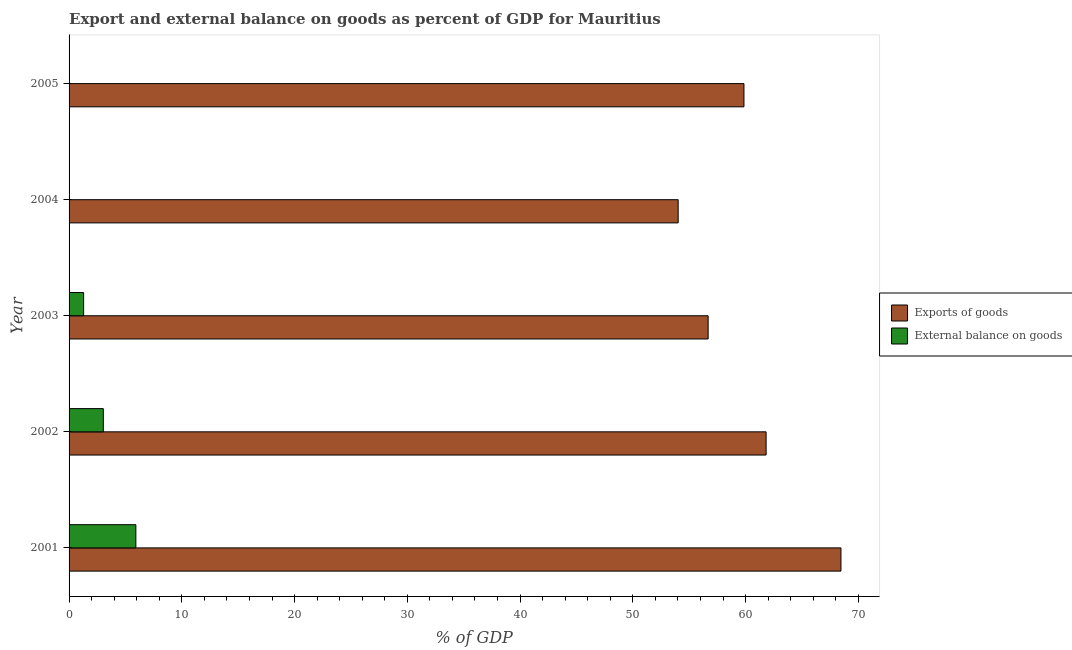How many different coloured bars are there?
Your response must be concise. 2. Are the number of bars per tick equal to the number of legend labels?
Offer a very short reply. No. What is the label of the 3rd group of bars from the top?
Make the answer very short. 2003. In how many cases, is the number of bars for a given year not equal to the number of legend labels?
Your response must be concise. 2. What is the export of goods as percentage of gdp in 2001?
Your answer should be compact. 68.46. Across all years, what is the maximum export of goods as percentage of gdp?
Provide a short and direct response. 68.46. Across all years, what is the minimum export of goods as percentage of gdp?
Ensure brevity in your answer.  54.02. In which year was the export of goods as percentage of gdp maximum?
Make the answer very short. 2001. What is the total external balance on goods as percentage of gdp in the graph?
Provide a succinct answer. 10.25. What is the difference between the export of goods as percentage of gdp in 2002 and that in 2005?
Your answer should be compact. 1.96. What is the difference between the external balance on goods as percentage of gdp in 2004 and the export of goods as percentage of gdp in 2005?
Offer a very short reply. -59.85. What is the average external balance on goods as percentage of gdp per year?
Keep it short and to the point. 2.05. In the year 2002, what is the difference between the export of goods as percentage of gdp and external balance on goods as percentage of gdp?
Your answer should be compact. 58.78. In how many years, is the external balance on goods as percentage of gdp greater than 44 %?
Provide a succinct answer. 0. What is the ratio of the export of goods as percentage of gdp in 2002 to that in 2005?
Give a very brief answer. 1.03. Is the external balance on goods as percentage of gdp in 2001 less than that in 2002?
Give a very brief answer. No. What is the difference between the highest and the second highest export of goods as percentage of gdp?
Provide a succinct answer. 6.64. What is the difference between the highest and the lowest external balance on goods as percentage of gdp?
Provide a succinct answer. 5.92. In how many years, is the export of goods as percentage of gdp greater than the average export of goods as percentage of gdp taken over all years?
Make the answer very short. 2. Are all the bars in the graph horizontal?
Give a very brief answer. Yes. How many years are there in the graph?
Provide a short and direct response. 5. What is the difference between two consecutive major ticks on the X-axis?
Offer a terse response. 10. Are the values on the major ticks of X-axis written in scientific E-notation?
Provide a succinct answer. No. Does the graph contain any zero values?
Your answer should be very brief. Yes. Does the graph contain grids?
Your response must be concise. No. How many legend labels are there?
Your answer should be very brief. 2. What is the title of the graph?
Give a very brief answer. Export and external balance on goods as percent of GDP for Mauritius. What is the label or title of the X-axis?
Your answer should be very brief. % of GDP. What is the label or title of the Y-axis?
Offer a very short reply. Year. What is the % of GDP in Exports of goods in 2001?
Your answer should be compact. 68.46. What is the % of GDP of External balance on goods in 2001?
Provide a succinct answer. 5.92. What is the % of GDP of Exports of goods in 2002?
Provide a succinct answer. 61.82. What is the % of GDP of External balance on goods in 2002?
Your response must be concise. 3.04. What is the % of GDP in Exports of goods in 2003?
Provide a succinct answer. 56.68. What is the % of GDP of External balance on goods in 2003?
Ensure brevity in your answer.  1.29. What is the % of GDP of Exports of goods in 2004?
Offer a terse response. 54.02. What is the % of GDP in External balance on goods in 2004?
Provide a succinct answer. 0. What is the % of GDP of Exports of goods in 2005?
Your answer should be compact. 59.85. What is the % of GDP of External balance on goods in 2005?
Give a very brief answer. 0. Across all years, what is the maximum % of GDP of Exports of goods?
Your answer should be very brief. 68.46. Across all years, what is the maximum % of GDP of External balance on goods?
Give a very brief answer. 5.92. Across all years, what is the minimum % of GDP in Exports of goods?
Give a very brief answer. 54.02. Across all years, what is the minimum % of GDP of External balance on goods?
Your answer should be very brief. 0. What is the total % of GDP of Exports of goods in the graph?
Give a very brief answer. 300.83. What is the total % of GDP of External balance on goods in the graph?
Ensure brevity in your answer.  10.25. What is the difference between the % of GDP of Exports of goods in 2001 and that in 2002?
Offer a very short reply. 6.64. What is the difference between the % of GDP in External balance on goods in 2001 and that in 2002?
Ensure brevity in your answer.  2.89. What is the difference between the % of GDP in Exports of goods in 2001 and that in 2003?
Ensure brevity in your answer.  11.78. What is the difference between the % of GDP in External balance on goods in 2001 and that in 2003?
Give a very brief answer. 4.63. What is the difference between the % of GDP in Exports of goods in 2001 and that in 2004?
Provide a succinct answer. 14.44. What is the difference between the % of GDP of Exports of goods in 2001 and that in 2005?
Provide a short and direct response. 8.6. What is the difference between the % of GDP of Exports of goods in 2002 and that in 2003?
Provide a succinct answer. 5.14. What is the difference between the % of GDP of External balance on goods in 2002 and that in 2003?
Offer a terse response. 1.75. What is the difference between the % of GDP in Exports of goods in 2002 and that in 2004?
Provide a short and direct response. 7.8. What is the difference between the % of GDP in Exports of goods in 2002 and that in 2005?
Your response must be concise. 1.96. What is the difference between the % of GDP in Exports of goods in 2003 and that in 2004?
Make the answer very short. 2.66. What is the difference between the % of GDP in Exports of goods in 2003 and that in 2005?
Give a very brief answer. -3.18. What is the difference between the % of GDP in Exports of goods in 2004 and that in 2005?
Keep it short and to the point. -5.83. What is the difference between the % of GDP of Exports of goods in 2001 and the % of GDP of External balance on goods in 2002?
Offer a terse response. 65.42. What is the difference between the % of GDP of Exports of goods in 2001 and the % of GDP of External balance on goods in 2003?
Make the answer very short. 67.17. What is the difference between the % of GDP in Exports of goods in 2002 and the % of GDP in External balance on goods in 2003?
Provide a succinct answer. 60.53. What is the average % of GDP of Exports of goods per year?
Make the answer very short. 60.17. What is the average % of GDP of External balance on goods per year?
Your answer should be compact. 2.05. In the year 2001, what is the difference between the % of GDP in Exports of goods and % of GDP in External balance on goods?
Your answer should be compact. 62.53. In the year 2002, what is the difference between the % of GDP in Exports of goods and % of GDP in External balance on goods?
Your answer should be compact. 58.78. In the year 2003, what is the difference between the % of GDP of Exports of goods and % of GDP of External balance on goods?
Offer a very short reply. 55.39. What is the ratio of the % of GDP of Exports of goods in 2001 to that in 2002?
Your response must be concise. 1.11. What is the ratio of the % of GDP in External balance on goods in 2001 to that in 2002?
Your response must be concise. 1.95. What is the ratio of the % of GDP in Exports of goods in 2001 to that in 2003?
Give a very brief answer. 1.21. What is the ratio of the % of GDP of External balance on goods in 2001 to that in 2003?
Your answer should be compact. 4.59. What is the ratio of the % of GDP of Exports of goods in 2001 to that in 2004?
Keep it short and to the point. 1.27. What is the ratio of the % of GDP in Exports of goods in 2001 to that in 2005?
Your answer should be very brief. 1.14. What is the ratio of the % of GDP of Exports of goods in 2002 to that in 2003?
Make the answer very short. 1.09. What is the ratio of the % of GDP in External balance on goods in 2002 to that in 2003?
Ensure brevity in your answer.  2.35. What is the ratio of the % of GDP in Exports of goods in 2002 to that in 2004?
Your response must be concise. 1.14. What is the ratio of the % of GDP in Exports of goods in 2002 to that in 2005?
Give a very brief answer. 1.03. What is the ratio of the % of GDP of Exports of goods in 2003 to that in 2004?
Ensure brevity in your answer.  1.05. What is the ratio of the % of GDP in Exports of goods in 2003 to that in 2005?
Your answer should be compact. 0.95. What is the ratio of the % of GDP in Exports of goods in 2004 to that in 2005?
Give a very brief answer. 0.9. What is the difference between the highest and the second highest % of GDP in Exports of goods?
Your answer should be compact. 6.64. What is the difference between the highest and the second highest % of GDP of External balance on goods?
Offer a terse response. 2.89. What is the difference between the highest and the lowest % of GDP in Exports of goods?
Give a very brief answer. 14.44. What is the difference between the highest and the lowest % of GDP in External balance on goods?
Give a very brief answer. 5.92. 